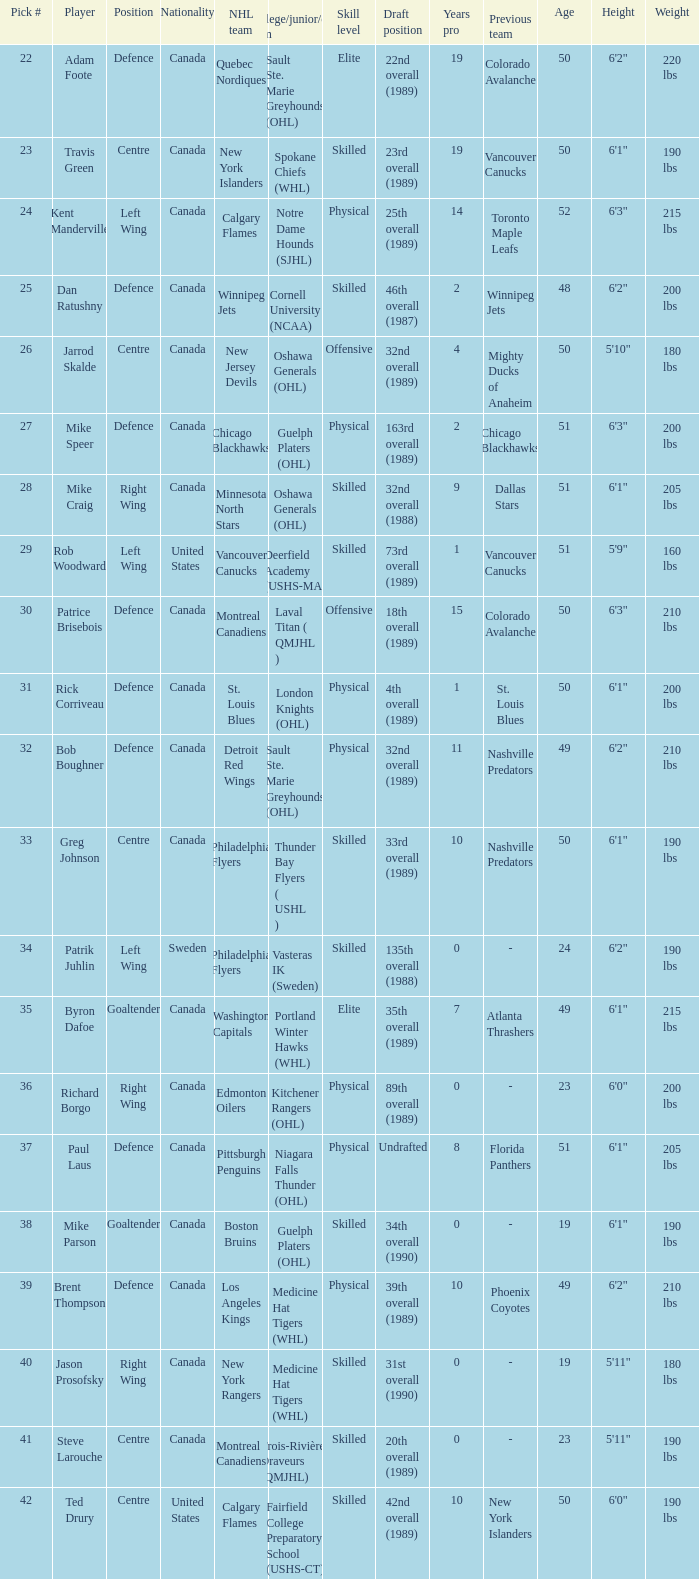What is the citizenship of the draft pick athlete who plays the center role and is joining the calgary flames? United States. 